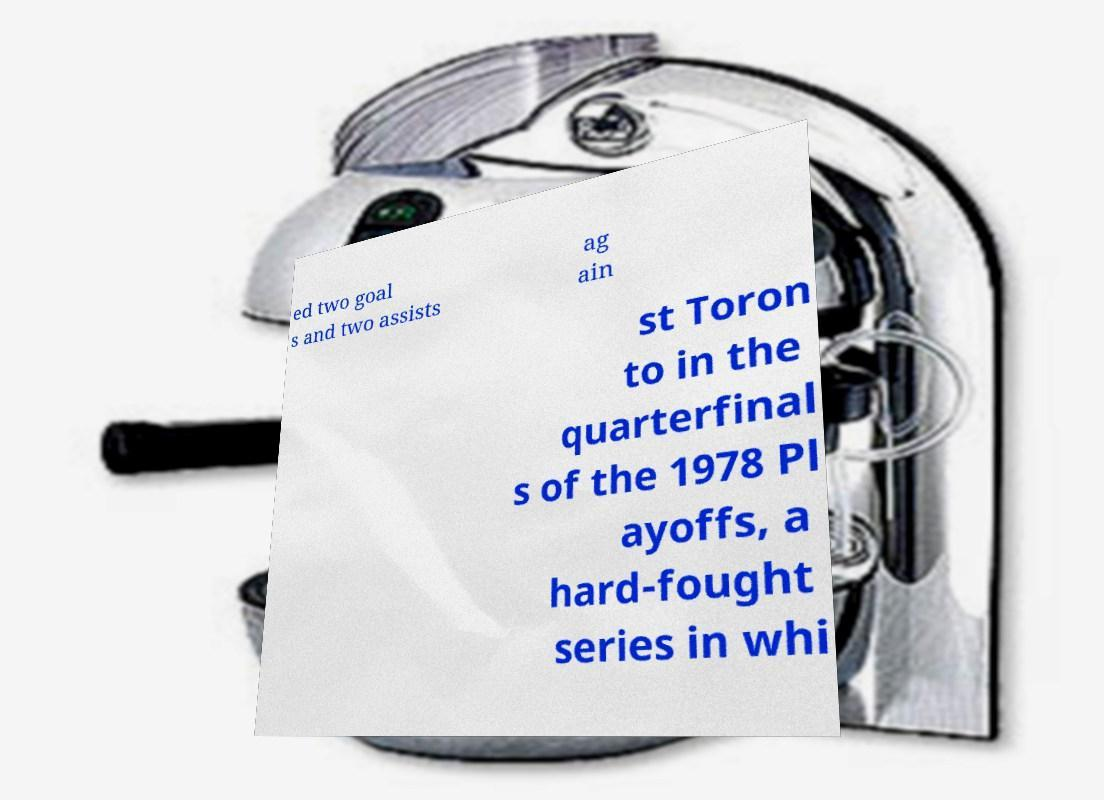There's text embedded in this image that I need extracted. Can you transcribe it verbatim? ed two goal s and two assists ag ain st Toron to in the quarterfinal s of the 1978 Pl ayoffs, a hard-fought series in whi 